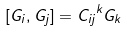Convert formula to latex. <formula><loc_0><loc_0><loc_500><loc_500>[ G _ { i } , G _ { j } ] = { C _ { i j } } ^ { k } G _ { k }</formula> 